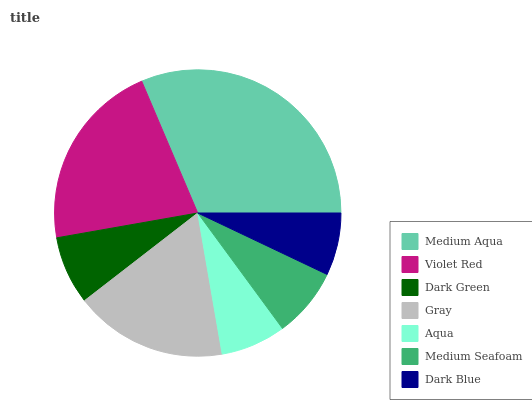Is Dark Blue the minimum?
Answer yes or no. Yes. Is Medium Aqua the maximum?
Answer yes or no. Yes. Is Violet Red the minimum?
Answer yes or no. No. Is Violet Red the maximum?
Answer yes or no. No. Is Medium Aqua greater than Violet Red?
Answer yes or no. Yes. Is Violet Red less than Medium Aqua?
Answer yes or no. Yes. Is Violet Red greater than Medium Aqua?
Answer yes or no. No. Is Medium Aqua less than Violet Red?
Answer yes or no. No. Is Medium Seafoam the high median?
Answer yes or no. Yes. Is Medium Seafoam the low median?
Answer yes or no. Yes. Is Violet Red the high median?
Answer yes or no. No. Is Gray the low median?
Answer yes or no. No. 